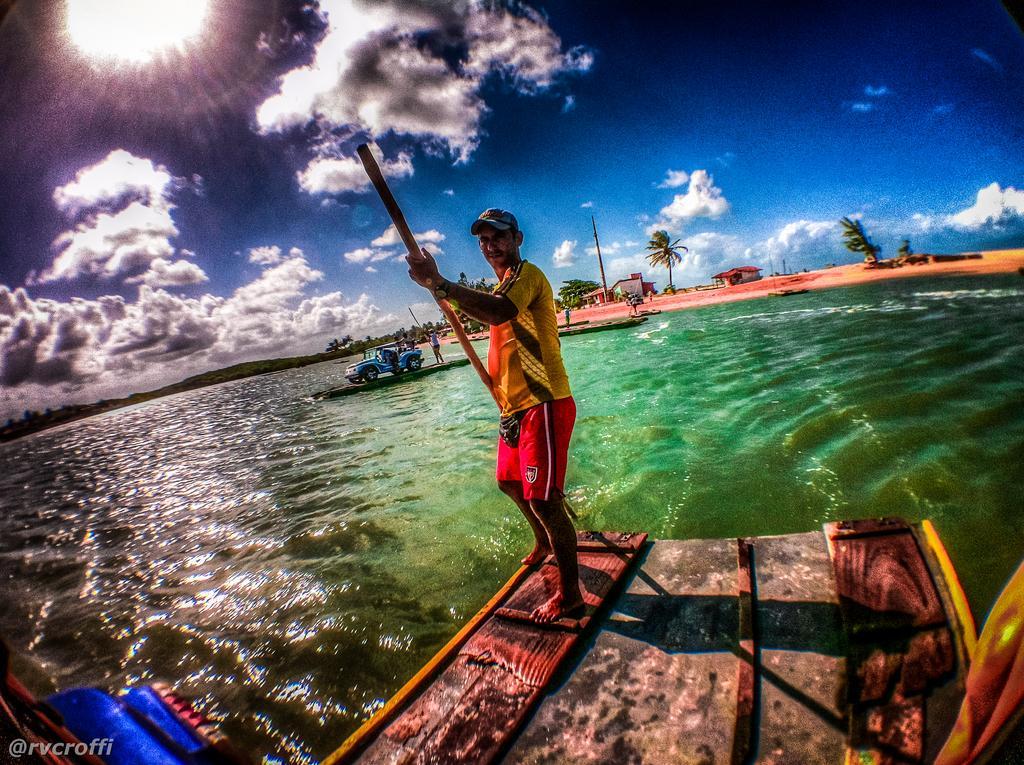In one or two sentences, can you explain what this image depicts? The man in yellow T-shirt who is wearing a cap is sailing the boat. Behind him, we see a jeep in blue color. There are buildings, trees and a pole in the background. At the top of the picture, we see the sky, clouds and the sun. 